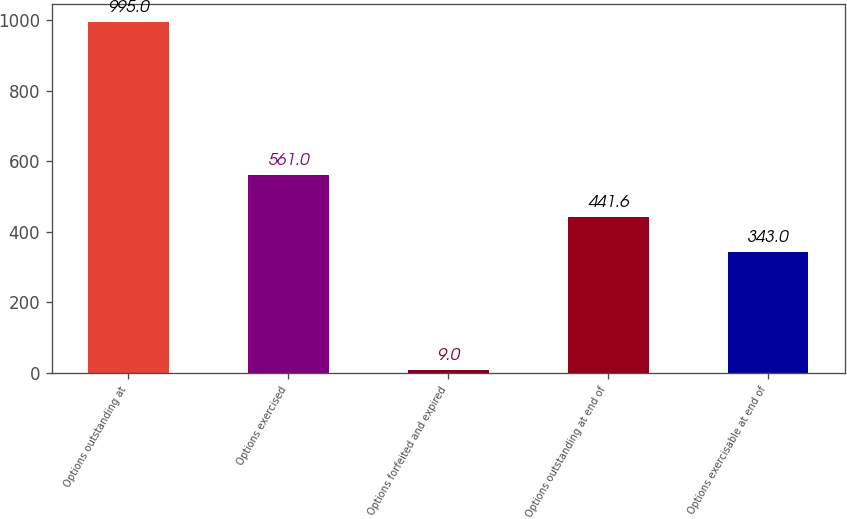Convert chart to OTSL. <chart><loc_0><loc_0><loc_500><loc_500><bar_chart><fcel>Options outstanding at<fcel>Options exercised<fcel>Options forfeited and expired<fcel>Options outstanding at end of<fcel>Options exercisable at end of<nl><fcel>995<fcel>561<fcel>9<fcel>441.6<fcel>343<nl></chart> 